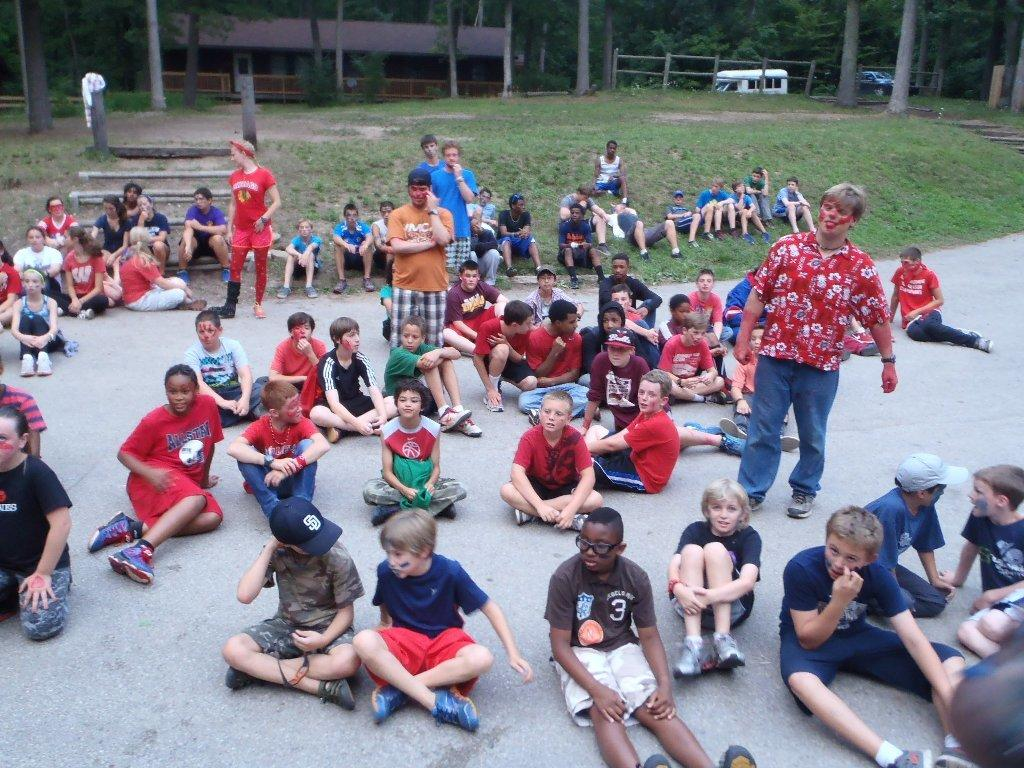How many people are in the image? There is a group of people in the image. What can be seen in the background of the image? There are stairs, trees, buildings, and grass in the image. How many vehicles are present in the image? There are two vehicles in the image. What type of brick is being used to build the songs in the image? There is no mention of songs or bricks in the image; it features a group of people, stairs, trees, buildings, grass, and two vehicles. 